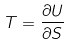<formula> <loc_0><loc_0><loc_500><loc_500>T = \frac { \partial U } { \partial S }</formula> 